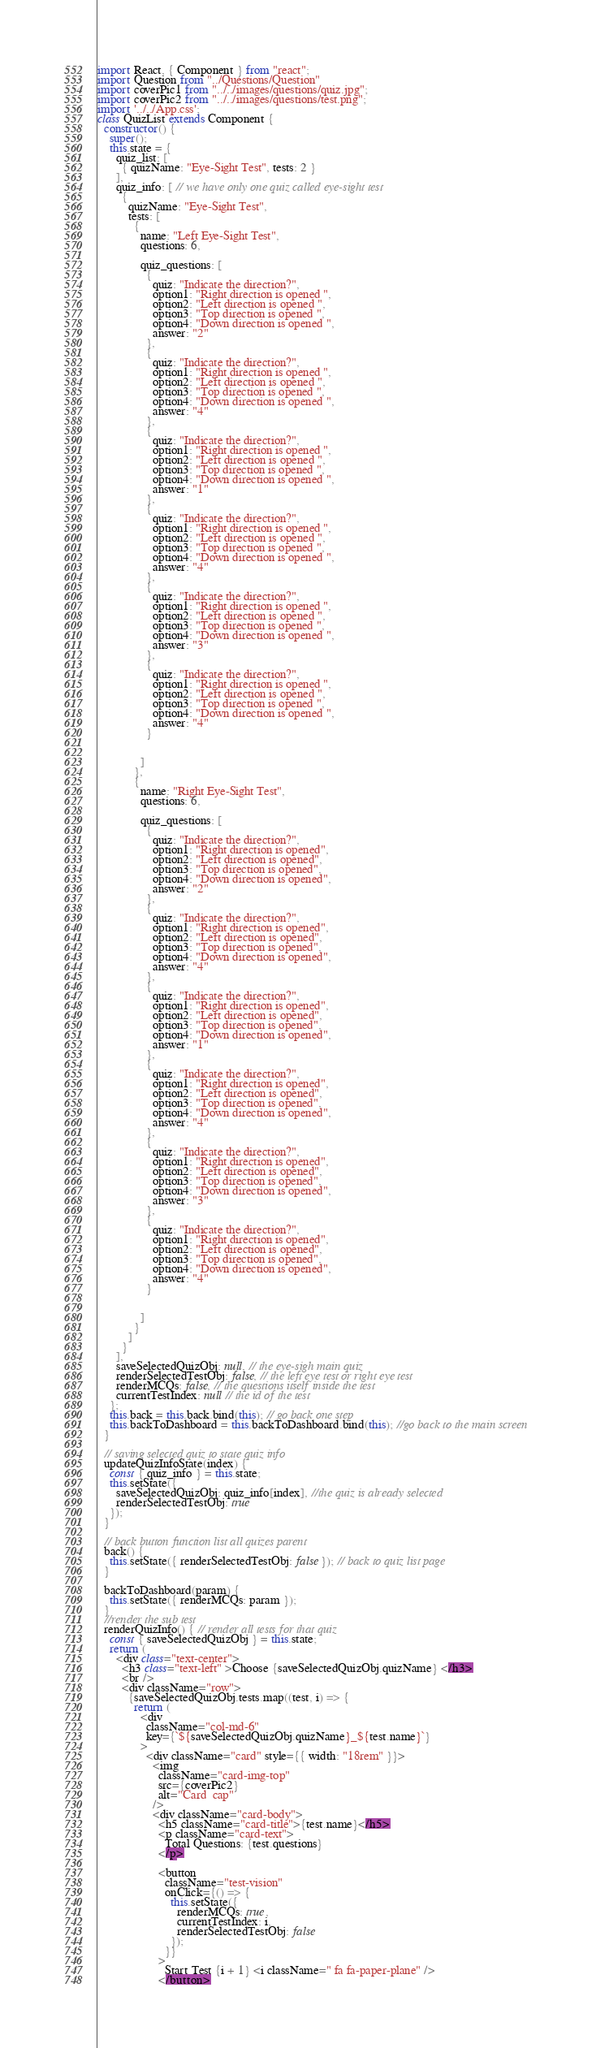<code> <loc_0><loc_0><loc_500><loc_500><_JavaScript_>import React, { Component } from "react";
import Question from "../Questions/Question"
import coverPic1 from "../../images/questions/quiz.jpg";
import coverPic2 from "../../images/questions/test.png";
import '../../App.css';
class QuizList extends Component {
  constructor() {
    super();
    this.state = {
      quiz_list: [
        { quizName: "Eye-Sight Test", tests: 2 }
      ],
      quiz_info: [ // we have only one quiz called eye-sight test
        {
          quizName: "Eye-Sight Test",
          tests: [
            {
              name: "Left Eye-Sight Test",
              questions: 6,

              quiz_questions: [
                {
                  quiz: "Indicate the direction?",
                  option1: "Right direction is opened ",
                  option2: "Left direction is opened ",
                  option3: "Top direction is opened ",
                  option4: "Down direction is opened ",
                  answer: "2"
                },
                {
                  quiz: "Indicate the direction?",
                  option1: "Right direction is opened ",
                  option2: "Left direction is opened ",
                  option3: "Top direction is opened ",
                  option4: "Down direction is opened ",
                  answer: "4"
                },
                {
                  quiz: "Indicate the direction?",
                  option1: "Right direction is opened ",
                  option2: "Left direction is opened ",
                  option3: "Top direction is opened ",
                  option4: "Down direction is opened ",
                  answer: "1"
                },
                {
                  quiz: "Indicate the direction?",
                  option1: "Right direction is opened ",
                  option2: "Left direction is opened ",
                  option3: "Top direction is opened ",
                  option4: "Down direction is opened ",
                  answer: "4"
                },
                {
                  quiz: "Indicate the direction?",
                  option1: "Right direction is opened ",
                  option2: "Left direction is opened ",
                  option3: "Top direction is opened ",
                  option4: "Down direction is opened ",
                  answer: "3"
                },
                {
                  quiz: "Indicate the direction?",
                  option1: "Right direction is opened ",
                  option2: "Left direction is opened ",
                  option3: "Top direction is opened ",
                  option4: "Down direction is opened ",
                  answer: "4"
                }


              ]
            },
            {
              name: "Right Eye-Sight Test",
              questions: 6,

              quiz_questions: [
                {
                  quiz: "Indicate the direction?",
                  option1: "Right direction is opened",
                  option2: "Left direction is opened",
                  option3: "Top direction is opened",
                  option4: "Down direction is opened",
                  answer: "2"
                },
                {
                  quiz: "Indicate the direction?",
                  option1: "Right direction is opened",
                  option2: "Left direction is opened",
                  option3: "Top direction is opened",
                  option4: "Down direction is opened",
                  answer: "4"
                },
                {
                  quiz: "Indicate the direction?",
                  option1: "Right direction is opened",
                  option2: "Left direction is opened",
                  option3: "Top direction is opened",
                  option4: "Down direction is opened",
                  answer: "1"
                },
                {
                  quiz: "Indicate the direction?",
                  option1: "Right direction is opened",
                  option2: "Left direction is opened",
                  option3: "Top direction is opened",
                  option4: "Down direction is opened",
                  answer: "4"
                },
                {
                  quiz: "Indicate the direction?",
                  option1: "Right direction is opened",
                  option2: "Left direction is opened",
                  option3: "Top direction is opened",
                  option4: "Down direction is opened",
                  answer: "3"
                },
                {
                  quiz: "Indicate the direction?",
                  option1: "Right direction is opened",
                  option2: "Left direction is opened",
                  option3: "Top direction is opened",
                  option4: "Down direction is opened",
                  answer: "4"
                }


              ]
            }
          ]
        }
      ],
      saveSelectedQuizObj: null, // the eye-sigh main quiz
      renderSelectedTestObj: false, // the left eye test or right eye test
      renderMCQs: false, // the questions itself inside the test 
      currentTestIndex: null // the id of the test
    };
    this.back = this.back.bind(this); // go back one step 
    this.backToDashboard = this.backToDashboard.bind(this); //go back to the main screen
  }

  // saving selected quiz to state quiz info
  updateQuizInfoState(index) {
    const { quiz_info } = this.state;
    this.setState({
      saveSelectedQuizObj: quiz_info[index], //the quiz is already selected 
      renderSelectedTestObj: true
    });
  }

  // back button function list all quizes parent 
  back() {
    this.setState({ renderSelectedTestObj: false }); // back to quiz list page
  }

  backToDashboard(param) {
    this.setState({ renderMCQs: param });
  }
  //render the sub test
  renderQuizInfo() { // render all tests for that quiz
    const { saveSelectedQuizObj } = this.state;
    return (
      <div class="text-center">
        <h3 class="text-left" >Choose {saveSelectedQuizObj.quizName} </h3>
        <br />
        <div className="row">
          {saveSelectedQuizObj.tests.map((test, i) => {
            return (
              <div
                className="col-md-6"
                key={`${saveSelectedQuizObj.quizName}_${test.name}`}
              >
                <div className="card" style={{ width: "18rem" }}>
                  <img
                    className="card-img-top"
                    src={coverPic2}
                    alt="Card  cap"
                  />
                  <div className="card-body">
                    <h5 className="card-title">{test.name}</h5>
                    <p className="card-text">
                      Total Questions: {test.questions}
                    </p>

                    <button
                      className="test-vision"
                      onClick={() => {
                        this.setState({
                          renderMCQs: true,
                          currentTestIndex: i,
                          renderSelectedTestObj: false
                        });
                      }}
                    >
                      Start Test {i + 1} <i className=" fa fa-paper-plane" />
                    </button></code> 